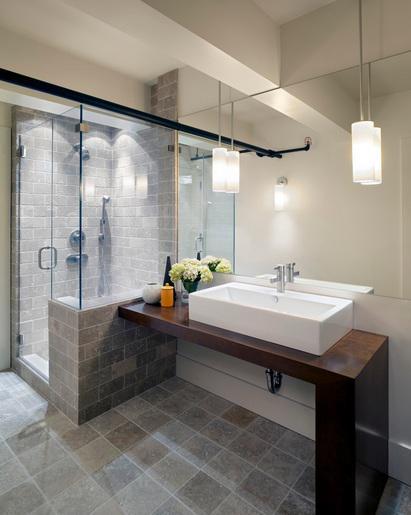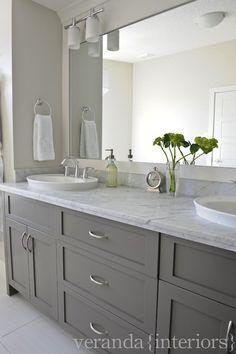The first image is the image on the left, the second image is the image on the right. For the images shown, is this caption "The flowers in the vase are pink." true? Answer yes or no. No. 